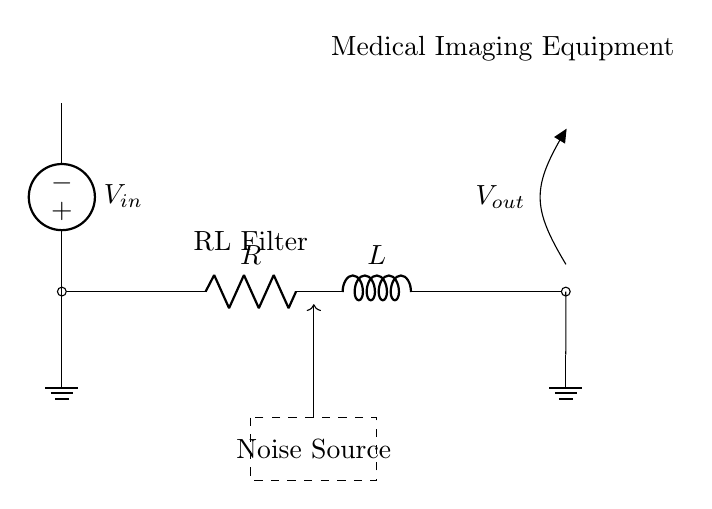What type of filter does this circuit implement? The circuit features a resistor and an inductor, indicating that it operates as an RL filter. It is designed to reduce noise in a signal.
Answer: RL filter What is the purpose of the inductor in this circuit? The inductor in this circuit opposes changes in current, which helps in filtering out the noise along with the resistor, allowing only certain frequencies to pass while attenuating others.
Answer: Noise reduction What is the function of the resistor in this RL circuit? The resistor provides a means to dissipate energy, thus affecting the overall impedance and controlling how the circuit responds to various frequencies, enabling further noise reduction in the output signal.
Answer: Current control What is the name of the voltage source in the circuit? The voltage source is labeled as V in the circuit diagram, which provides the input voltage necessary for the operation of the filter.
Answer: V in How does the output voltage compare to the input voltage with respect to noise reduction? The output voltage is typically less than the input voltage due to filtering; the RL filter attenuates certain frequencies, which means unwanted noise is reduced in the output compared to the input.
Answer: Reduced What happens to high-frequency noise components in this RL filter? High-frequency noise components are primarily attenuated or reduced because the inductor creates an impedance that increases with frequency, thereby suppressing those frequencies in the output.
Answer: Attenuated What element in this circuit acts as a noise source? The rectangular dashed area labeled 'Noise Source' in the diagram indicates the location or origin of unwanted signals or noise that the circuit is designed to filter out.
Answer: Noise Source 